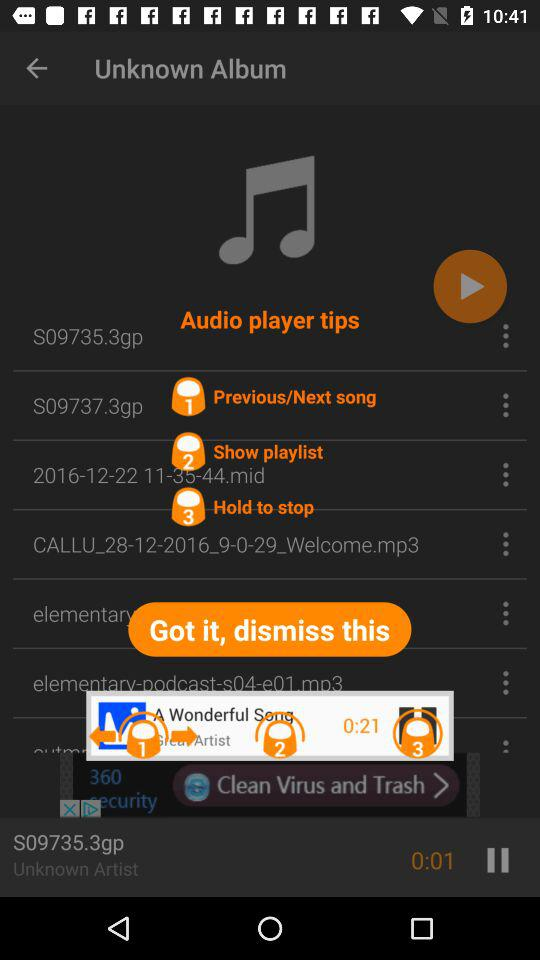What is the duration of the song "S09735.3gp"? The duration of the song is 1 second. 